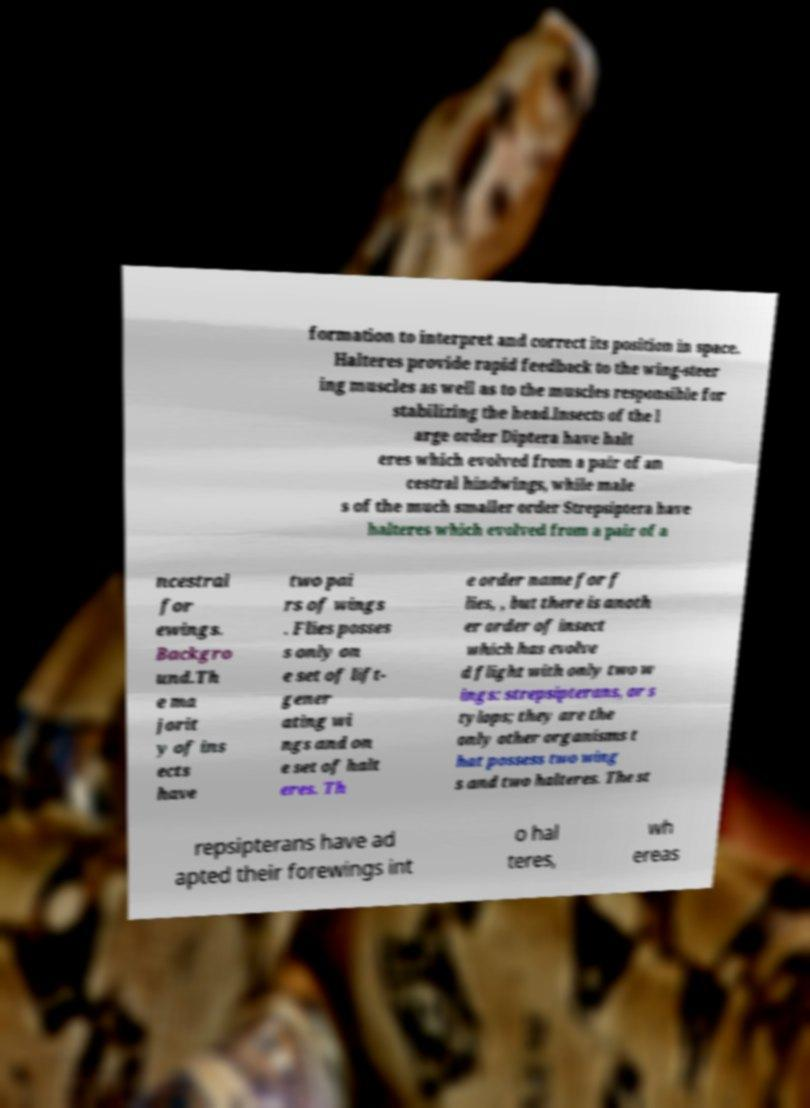For documentation purposes, I need the text within this image transcribed. Could you provide that? formation to interpret and correct its position in space. Halteres provide rapid feedback to the wing-steer ing muscles as well as to the muscles responsible for stabilizing the head.Insects of the l arge order Diptera have halt eres which evolved from a pair of an cestral hindwings, while male s of the much smaller order Strepsiptera have halteres which evolved from a pair of a ncestral for ewings. Backgro und.Th e ma jorit y of ins ects have two pai rs of wings . Flies posses s only on e set of lift- gener ating wi ngs and on e set of halt eres. Th e order name for f lies, , but there is anoth er order of insect which has evolve d flight with only two w ings: strepsipterans, or s tylops; they are the only other organisms t hat possess two wing s and two halteres. The st repsipterans have ad apted their forewings int o hal teres, wh ereas 